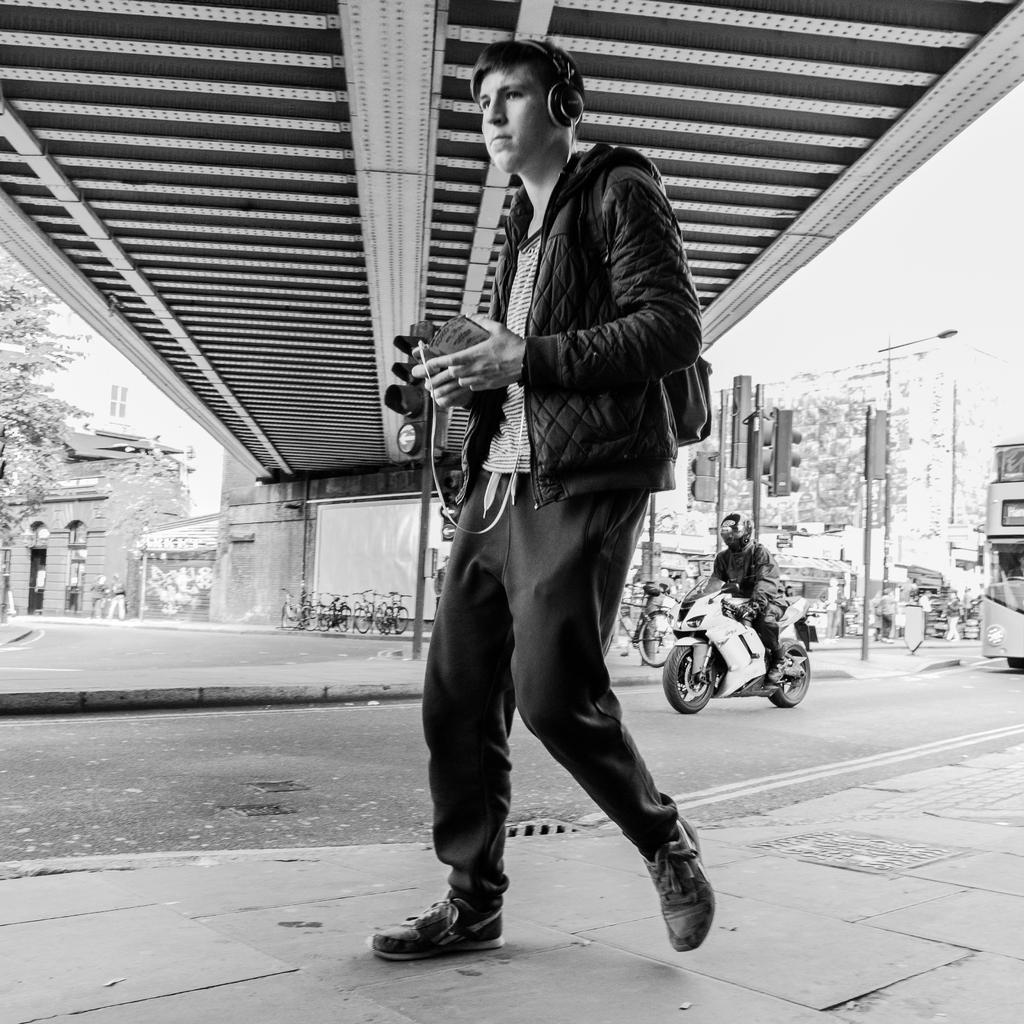How would you summarize this image in a sentence or two? The picture is taken on the streets. In the foreground of the picture there is a man walking on the pavement. To the right on the road there is a person driving motorbike. To the right there is a bus. On the top right there are signal lights, trees, buildings, and a street light. In the center background there are cycles, walls and a bridge. In the top left their buildings and tree. 